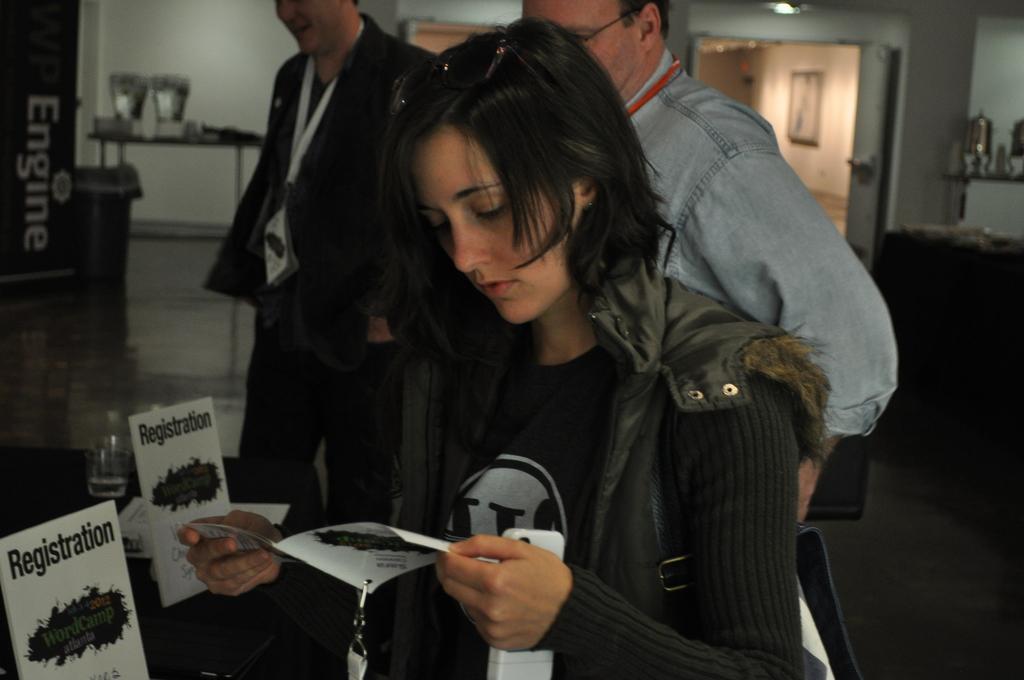Can you describe this image briefly? In this image I can see three people with different color dresses. In-front of these people I can see the glass and some boards on the black color surface. In the background I can see the board and some objects. To the right I can see the something is attached to the wall and there is a light in the top. 